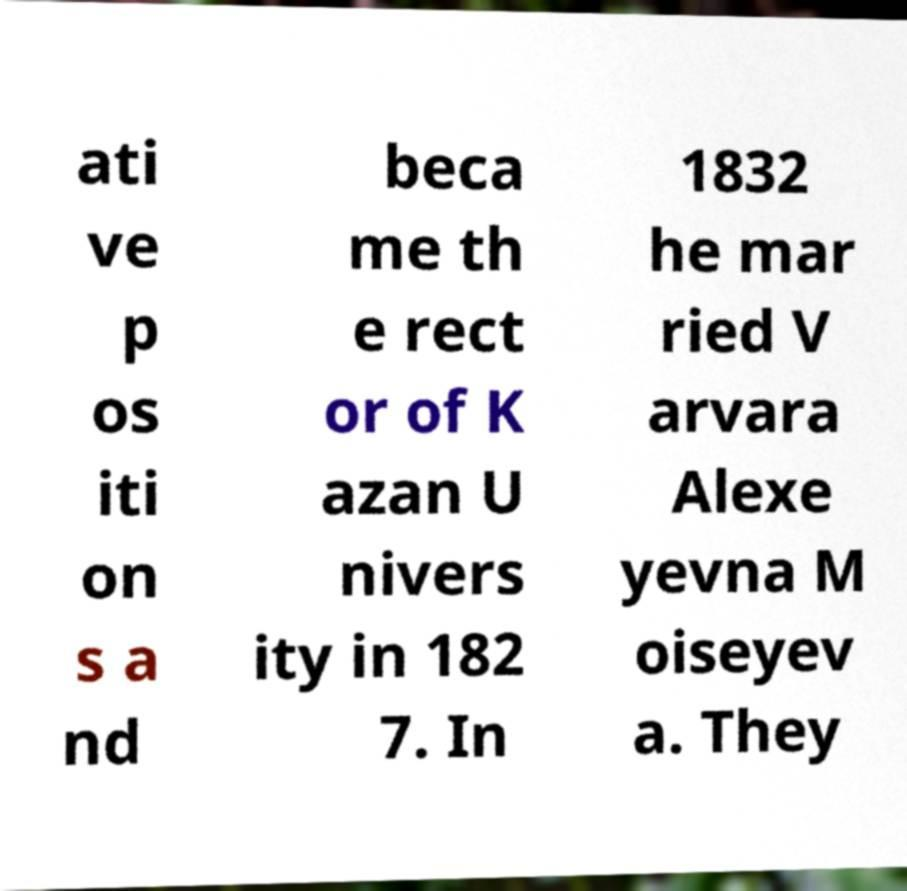There's text embedded in this image that I need extracted. Can you transcribe it verbatim? ati ve p os iti on s a nd beca me th e rect or of K azan U nivers ity in 182 7. In 1832 he mar ried V arvara Alexe yevna M oiseyev a. They 